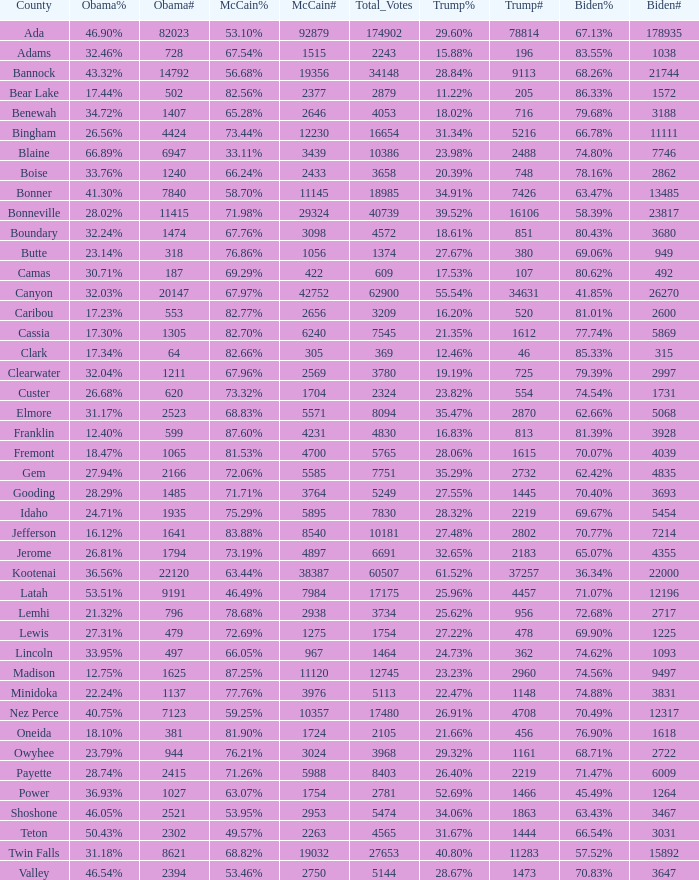What is the maximum McCain population turnout number? 92879.0. 